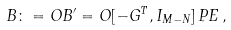<formula> <loc_0><loc_0><loc_500><loc_500>B \colon = O B ^ { \prime } = O [ - G ^ { T } , I _ { M - N } ] \, P E \, ,</formula> 